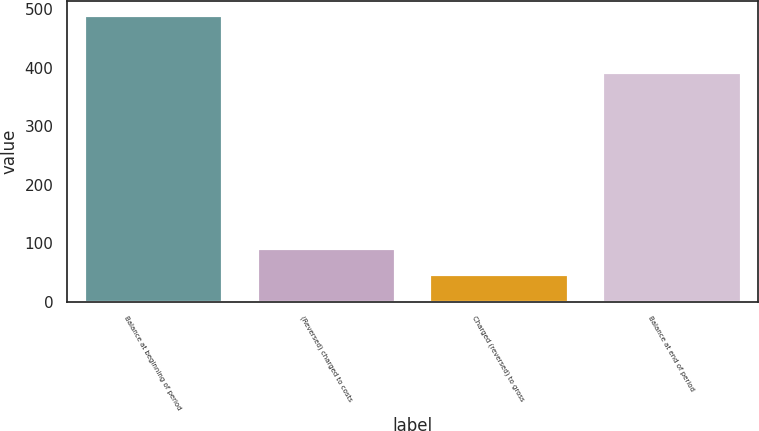<chart> <loc_0><loc_0><loc_500><loc_500><bar_chart><fcel>Balance at beginning of period<fcel>(Reversed) charged to costs<fcel>Charged (reversed) to gross<fcel>Balance at end of period<nl><fcel>489.9<fcel>91.74<fcel>47.5<fcel>392.9<nl></chart> 